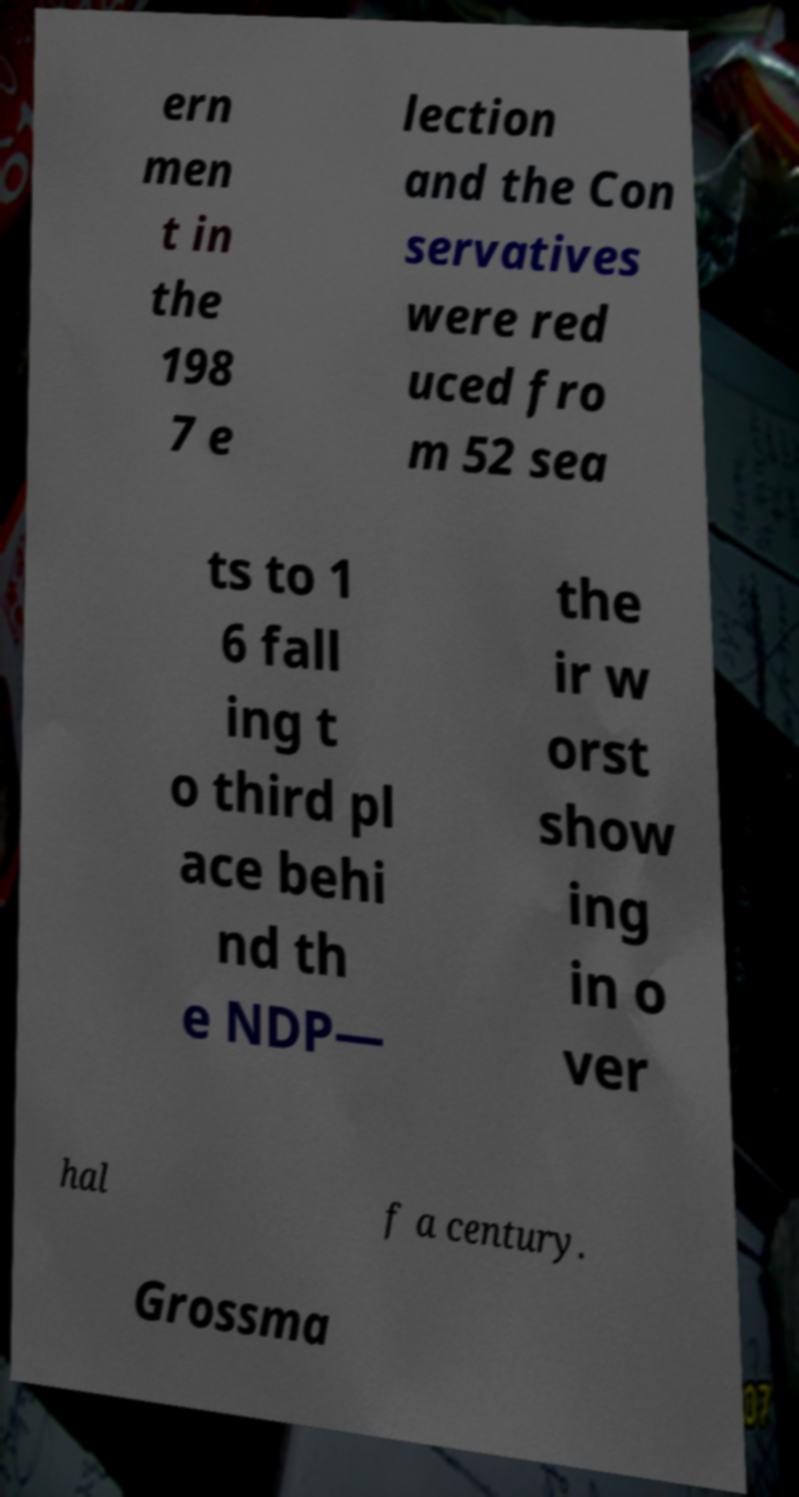What messages or text are displayed in this image? I need them in a readable, typed format. ern men t in the 198 7 e lection and the Con servatives were red uced fro m 52 sea ts to 1 6 fall ing t o third pl ace behi nd th e NDP— the ir w orst show ing in o ver hal f a century. Grossma 